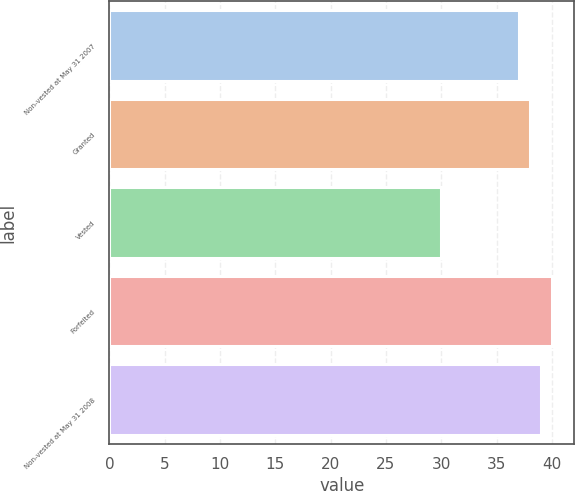Convert chart. <chart><loc_0><loc_0><loc_500><loc_500><bar_chart><fcel>Non-vested at May 31 2007<fcel>Granted<fcel>Vested<fcel>Forfeited<fcel>Non-vested at May 31 2008<nl><fcel>37<fcel>38<fcel>30<fcel>40<fcel>39<nl></chart> 